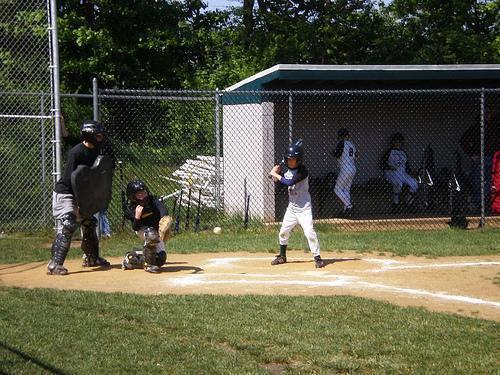Where do those who await their turn at bat wait?
From the following four choices, select the correct answer to address the question.
Options: Mall, home base, behind fence, outfield. Behind fence. 